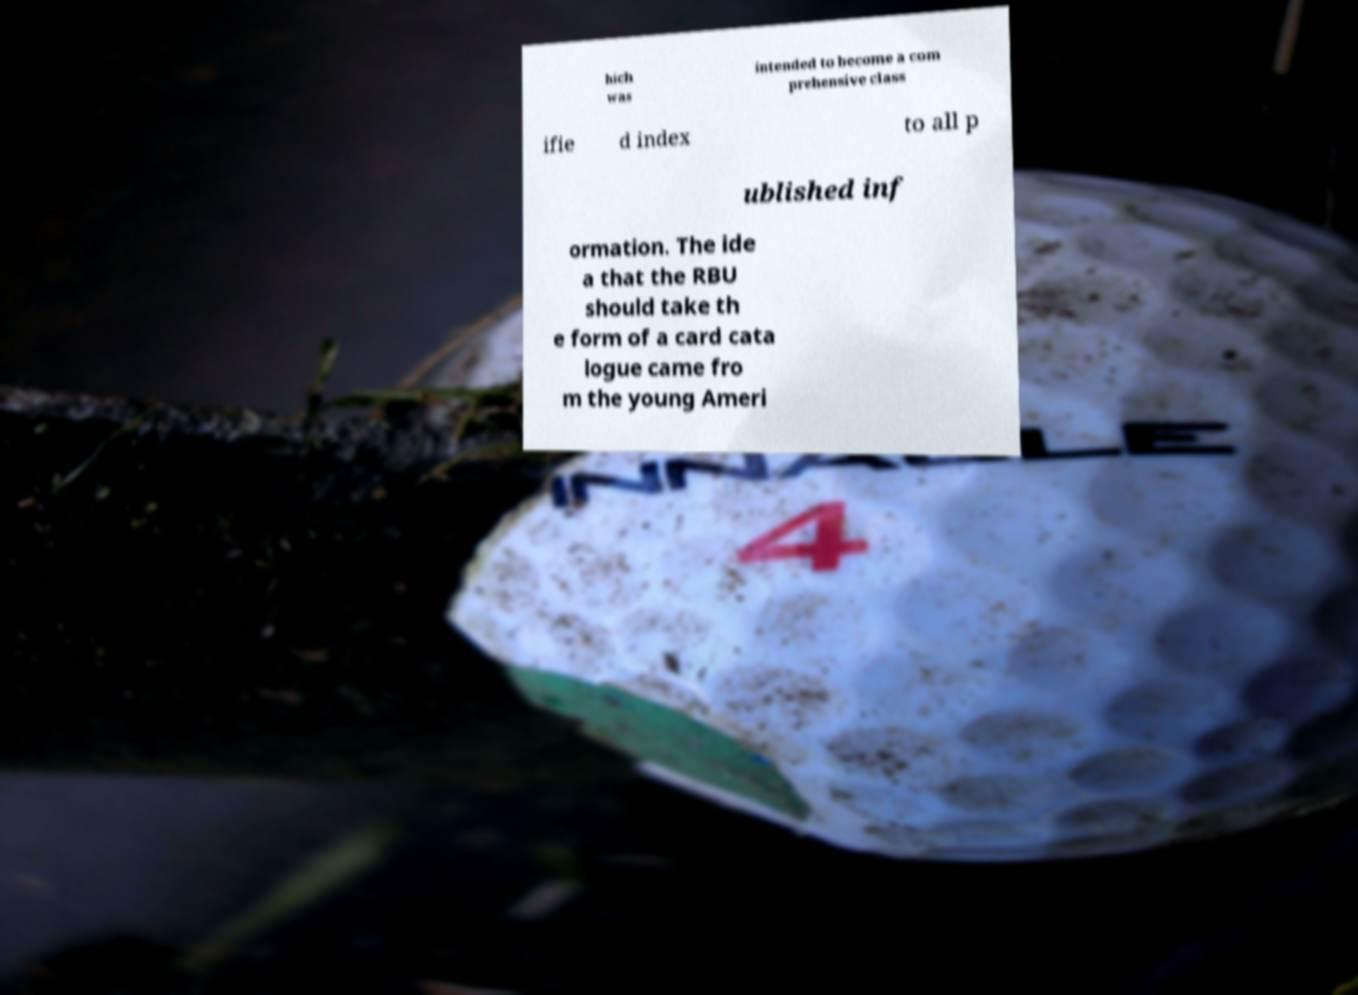What messages or text are displayed in this image? I need them in a readable, typed format. hich was intended to become a com prehensive class ifie d index to all p ublished inf ormation. The ide a that the RBU should take th e form of a card cata logue came fro m the young Ameri 